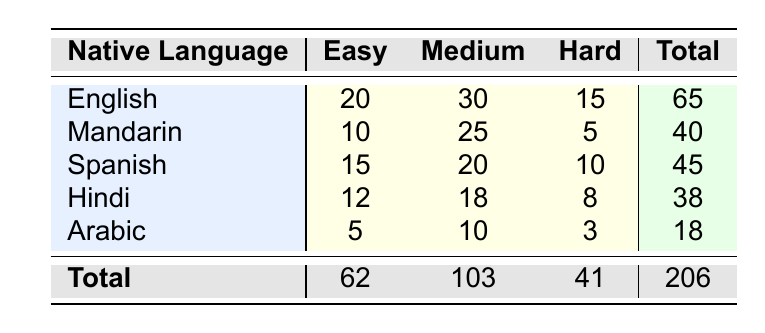What is the number of study group participants whose native language is Arabic and study a medium difficulty course? The table shows that for Arabic at medium difficulty, the number of study group participants is 10.
Answer: 10 What is the total number of study group participants for courses marked as hard? To find the total for hard courses, we sum up the values from the hard difficulty column: 15 (English) + 5 (Mandarin) + 10 (Spanish) + 8 (Hindi) + 3 (Arabic) = 41.
Answer: 41 Does Spanish have a higher study group participation in easy courses compared to Mandarin? For easy courses, Spanish has 15 participants and Mandarin has 10 participants. Since 15 is greater than 10, the answer is yes.
Answer: Yes Which native language has the highest total number of study group participants? The totals are: English 65, Mandarin 40, Spanish 45, Hindi 38, Arabic 18. The highest total is 65 for English.
Answer: English What is the average number of study group participants for all native languages in difficult courses? For hard courses, we have a total of 41 participants (calculated previously). There are 5 native languages, so the average is 41/5 = 8.2.
Answer: 8.2 How many more participants are there in medium difficulty courses compared to easy difficulty courses overall? The totals for medium and easy courses are 103 and 62, respectively. The difference is 103 - 62 = 41.
Answer: 41 Is it true that Hindi native speakers have more participants in hard courses than Arabic native speakers? Hindi has 8 participants in hard courses, while Arabic has 3. Since 8 is greater than 3, the statement is true.
Answer: Yes What percentage of the total study group participants are represented by English native speakers? The total number of participants is 206. English has 65 participants. The percentage is (65/206) * 100 = approximately 31.55%.
Answer: 31.55% What is the total participation for the native language that has the least participation in hard courses? Arabic has the least participation in hard with 3 participants, so the total for Arabic is 18.
Answer: 18 